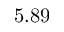Convert formula to latex. <formula><loc_0><loc_0><loc_500><loc_500>5 . 8 9</formula> 